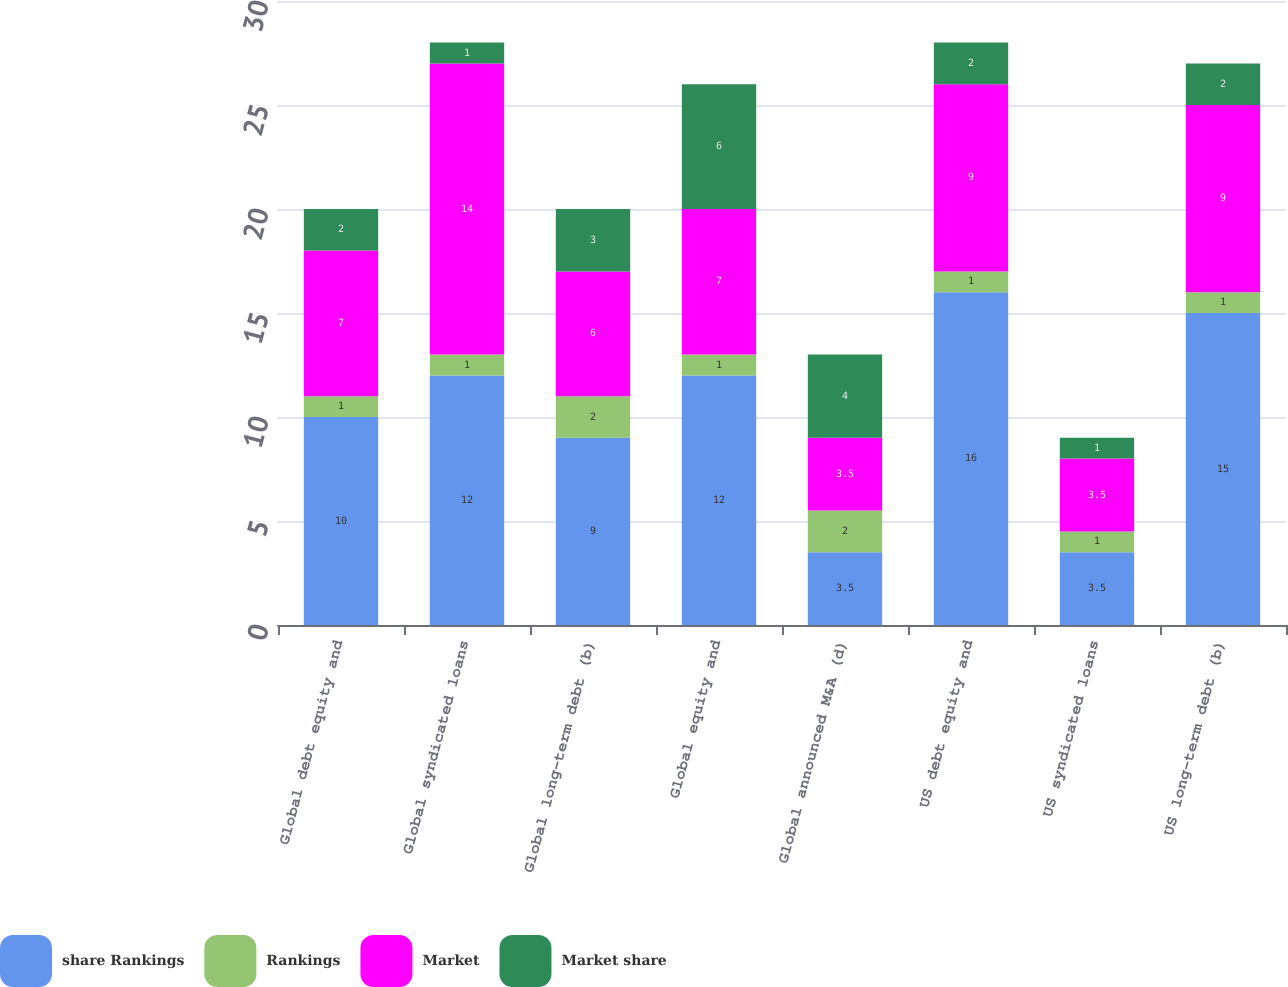Convert chart. <chart><loc_0><loc_0><loc_500><loc_500><stacked_bar_chart><ecel><fcel>Global debt equity and<fcel>Global syndicated loans<fcel>Global long-term debt (b)<fcel>Global equity and<fcel>Global announced M&A (d)<fcel>US debt equity and<fcel>US syndicated loans<fcel>US long-term debt (b)<nl><fcel>share Rankings<fcel>10<fcel>12<fcel>9<fcel>12<fcel>3.5<fcel>16<fcel>3.5<fcel>15<nl><fcel>Rankings<fcel>1<fcel>1<fcel>2<fcel>1<fcel>2<fcel>1<fcel>1<fcel>1<nl><fcel>Market<fcel>7<fcel>14<fcel>6<fcel>7<fcel>3.5<fcel>9<fcel>3.5<fcel>9<nl><fcel>Market share<fcel>2<fcel>1<fcel>3<fcel>6<fcel>4<fcel>2<fcel>1<fcel>2<nl></chart> 